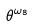<formula> <loc_0><loc_0><loc_500><loc_500>\theta ^ { \omega _ { 8 } }</formula> 